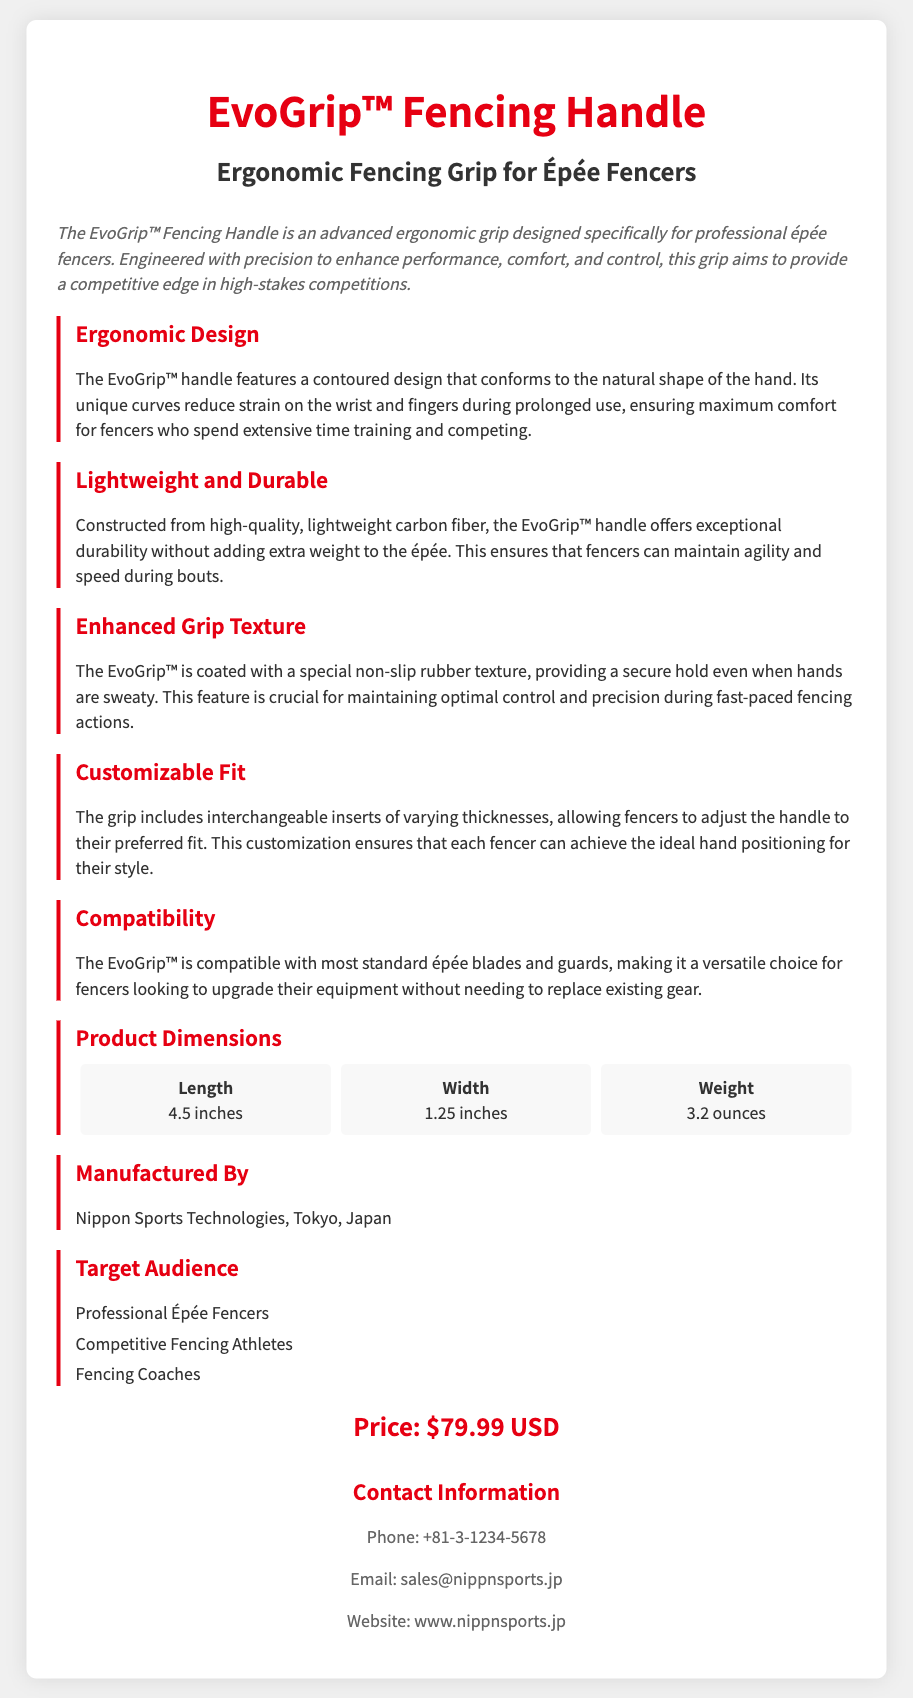What is the product name? The product name is listed prominently at the top of the document.
Answer: EvoGrip™ Fencing Handle What is the main material used for the handle? The material is mentioned in the section about durability.
Answer: Carbon fiber What is the weight of the EvoGrip™? The weight is provided in the product dimensions section.
Answer: 3.2 ounces What feature helps maintain grip in sweaty conditions? This feature is described in the section about grip texture.
Answer: Non-slip rubber texture Who manufactures the EvoGrip™? The manufacturer is specified in the section dedicated to manufacturing details.
Answer: Nippon Sports Technologies How long is the EvoGrip™ handle? The length is listed in the dimensions section of the document.
Answer: 4.5 inches What is the price of the EvoGrip™? The price is clearly stated in the pricing section.
Answer: $79.99 USD Who is the target audience for this product? The target audience is listed in a bullet point format under its own section.
Answer: Professional Épée Fencers What customization feature does the grip offer? The customization option is described in the section about fit.
Answer: Interchangeable inserts 